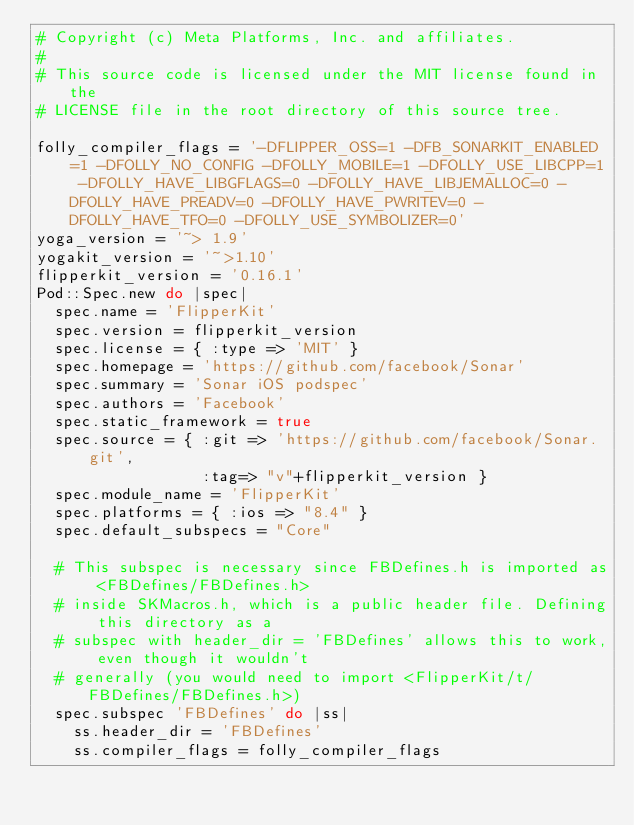<code> <loc_0><loc_0><loc_500><loc_500><_Ruby_># Copyright (c) Meta Platforms, Inc. and affiliates.
#
# This source code is licensed under the MIT license found in the
# LICENSE file in the root directory of this source tree.

folly_compiler_flags = '-DFLIPPER_OSS=1 -DFB_SONARKIT_ENABLED=1 -DFOLLY_NO_CONFIG -DFOLLY_MOBILE=1 -DFOLLY_USE_LIBCPP=1 -DFOLLY_HAVE_LIBGFLAGS=0 -DFOLLY_HAVE_LIBJEMALLOC=0 -DFOLLY_HAVE_PREADV=0 -DFOLLY_HAVE_PWRITEV=0 -DFOLLY_HAVE_TFO=0 -DFOLLY_USE_SYMBOLIZER=0'
yoga_version = '~> 1.9'
yogakit_version = '~>1.10'
flipperkit_version = '0.16.1'
Pod::Spec.new do |spec|
  spec.name = 'FlipperKit'
  spec.version = flipperkit_version
  spec.license = { :type => 'MIT' }
  spec.homepage = 'https://github.com/facebook/Sonar'
  spec.summary = 'Sonar iOS podspec'
  spec.authors = 'Facebook'
  spec.static_framework = true
  spec.source = { :git => 'https://github.com/facebook/Sonar.git',
                  :tag=> "v"+flipperkit_version }
  spec.module_name = 'FlipperKit'
  spec.platforms = { :ios => "8.4" }
  spec.default_subspecs = "Core"

  # This subspec is necessary since FBDefines.h is imported as <FBDefines/FBDefines.h>
  # inside SKMacros.h, which is a public header file. Defining this directory as a
  # subspec with header_dir = 'FBDefines' allows this to work, even though it wouldn't
  # generally (you would need to import <FlipperKit/t/FBDefines/FBDefines.h>)
  spec.subspec 'FBDefines' do |ss|
    ss.header_dir = 'FBDefines'
    ss.compiler_flags = folly_compiler_flags</code> 